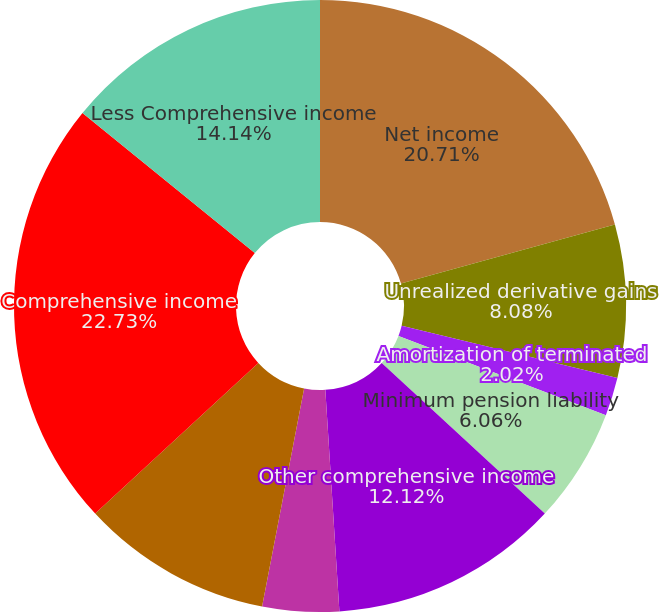<chart> <loc_0><loc_0><loc_500><loc_500><pie_chart><fcel>Net income<fcel>Unrealized derivative gains<fcel>Amortization of terminated<fcel>Minimum pension liability<fcel>Foreign currency translation<fcel>Other comprehensive income<fcel>Income tax (benefit) expense<fcel>Total other comprehensive<fcel>Comprehensive income<fcel>Less Comprehensive income<nl><fcel>20.7%<fcel>8.08%<fcel>2.02%<fcel>6.06%<fcel>0.0%<fcel>12.12%<fcel>4.04%<fcel>10.1%<fcel>22.72%<fcel>14.14%<nl></chart> 